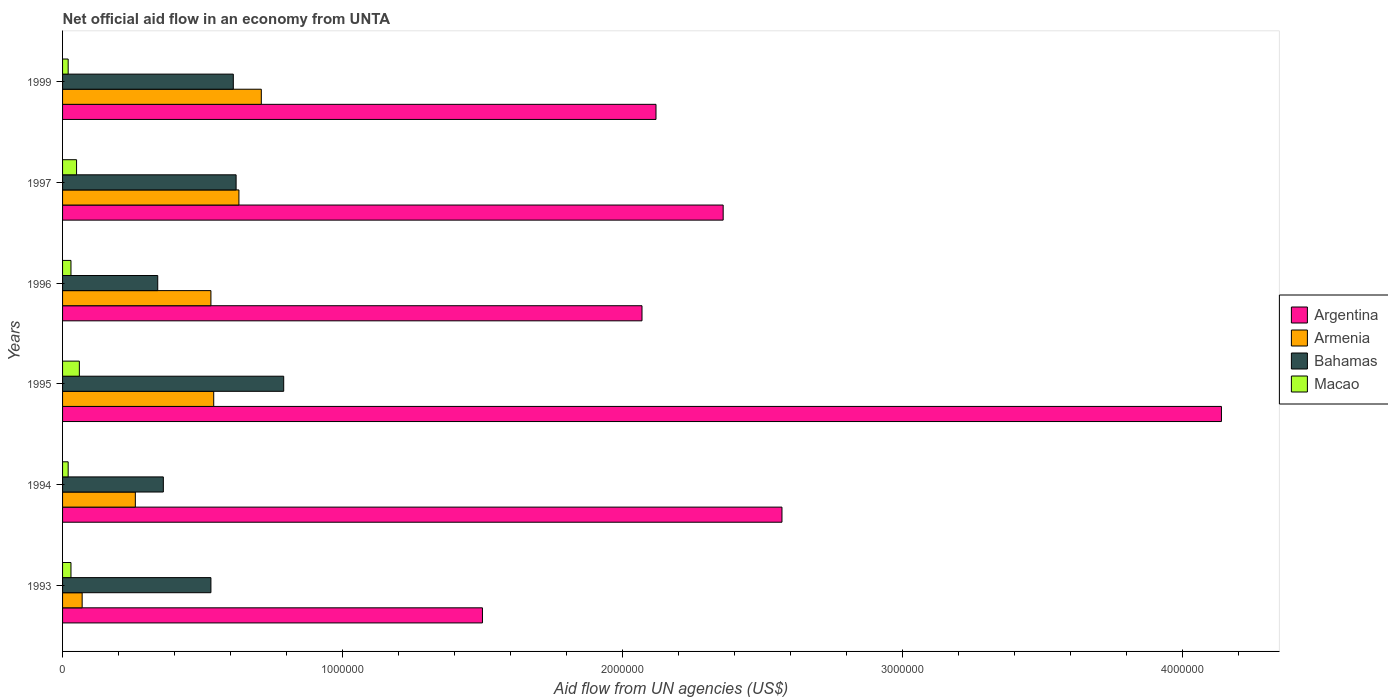Are the number of bars on each tick of the Y-axis equal?
Give a very brief answer. Yes. How many bars are there on the 2nd tick from the bottom?
Ensure brevity in your answer.  4. What is the label of the 4th group of bars from the top?
Your answer should be very brief. 1995. Across all years, what is the maximum net official aid flow in Argentina?
Provide a succinct answer. 4.14e+06. Across all years, what is the minimum net official aid flow in Bahamas?
Provide a short and direct response. 3.40e+05. In which year was the net official aid flow in Macao maximum?
Ensure brevity in your answer.  1995. In which year was the net official aid flow in Macao minimum?
Make the answer very short. 1994. What is the total net official aid flow in Argentina in the graph?
Offer a very short reply. 1.48e+07. What is the difference between the net official aid flow in Bahamas in 1996 and that in 1997?
Offer a very short reply. -2.80e+05. What is the difference between the net official aid flow in Argentina in 1995 and the net official aid flow in Bahamas in 1999?
Make the answer very short. 3.53e+06. What is the average net official aid flow in Argentina per year?
Offer a terse response. 2.46e+06. In the year 1994, what is the difference between the net official aid flow in Macao and net official aid flow in Argentina?
Your answer should be very brief. -2.55e+06. Is the net official aid flow in Bahamas in 1996 less than that in 1997?
Your response must be concise. Yes. What is the difference between the highest and the lowest net official aid flow in Bahamas?
Provide a succinct answer. 4.50e+05. In how many years, is the net official aid flow in Argentina greater than the average net official aid flow in Argentina taken over all years?
Keep it short and to the point. 2. What does the 4th bar from the top in 1996 represents?
Ensure brevity in your answer.  Argentina. What does the 3rd bar from the bottom in 1993 represents?
Offer a very short reply. Bahamas. Are all the bars in the graph horizontal?
Offer a terse response. Yes. How many years are there in the graph?
Keep it short and to the point. 6. What is the difference between two consecutive major ticks on the X-axis?
Give a very brief answer. 1.00e+06. Does the graph contain grids?
Ensure brevity in your answer.  No. How many legend labels are there?
Offer a terse response. 4. What is the title of the graph?
Offer a very short reply. Net official aid flow in an economy from UNTA. What is the label or title of the X-axis?
Provide a short and direct response. Aid flow from UN agencies (US$). What is the label or title of the Y-axis?
Keep it short and to the point. Years. What is the Aid flow from UN agencies (US$) of Argentina in 1993?
Your answer should be compact. 1.50e+06. What is the Aid flow from UN agencies (US$) of Armenia in 1993?
Your response must be concise. 7.00e+04. What is the Aid flow from UN agencies (US$) in Bahamas in 1993?
Ensure brevity in your answer.  5.30e+05. What is the Aid flow from UN agencies (US$) of Macao in 1993?
Offer a very short reply. 3.00e+04. What is the Aid flow from UN agencies (US$) of Argentina in 1994?
Make the answer very short. 2.57e+06. What is the Aid flow from UN agencies (US$) of Bahamas in 1994?
Make the answer very short. 3.60e+05. What is the Aid flow from UN agencies (US$) of Macao in 1994?
Keep it short and to the point. 2.00e+04. What is the Aid flow from UN agencies (US$) in Argentina in 1995?
Provide a short and direct response. 4.14e+06. What is the Aid flow from UN agencies (US$) of Armenia in 1995?
Ensure brevity in your answer.  5.40e+05. What is the Aid flow from UN agencies (US$) in Bahamas in 1995?
Your answer should be compact. 7.90e+05. What is the Aid flow from UN agencies (US$) in Argentina in 1996?
Provide a short and direct response. 2.07e+06. What is the Aid flow from UN agencies (US$) of Armenia in 1996?
Your answer should be very brief. 5.30e+05. What is the Aid flow from UN agencies (US$) in Argentina in 1997?
Give a very brief answer. 2.36e+06. What is the Aid flow from UN agencies (US$) of Armenia in 1997?
Ensure brevity in your answer.  6.30e+05. What is the Aid flow from UN agencies (US$) in Bahamas in 1997?
Give a very brief answer. 6.20e+05. What is the Aid flow from UN agencies (US$) of Argentina in 1999?
Your answer should be very brief. 2.12e+06. What is the Aid flow from UN agencies (US$) of Armenia in 1999?
Provide a short and direct response. 7.10e+05. What is the Aid flow from UN agencies (US$) of Bahamas in 1999?
Offer a terse response. 6.10e+05. What is the Aid flow from UN agencies (US$) of Macao in 1999?
Provide a succinct answer. 2.00e+04. Across all years, what is the maximum Aid flow from UN agencies (US$) in Argentina?
Make the answer very short. 4.14e+06. Across all years, what is the maximum Aid flow from UN agencies (US$) of Armenia?
Provide a short and direct response. 7.10e+05. Across all years, what is the maximum Aid flow from UN agencies (US$) in Bahamas?
Your answer should be compact. 7.90e+05. Across all years, what is the minimum Aid flow from UN agencies (US$) of Argentina?
Your answer should be compact. 1.50e+06. What is the total Aid flow from UN agencies (US$) of Argentina in the graph?
Your answer should be very brief. 1.48e+07. What is the total Aid flow from UN agencies (US$) in Armenia in the graph?
Your answer should be compact. 2.74e+06. What is the total Aid flow from UN agencies (US$) in Bahamas in the graph?
Keep it short and to the point. 3.25e+06. What is the difference between the Aid flow from UN agencies (US$) of Argentina in 1993 and that in 1994?
Provide a succinct answer. -1.07e+06. What is the difference between the Aid flow from UN agencies (US$) in Armenia in 1993 and that in 1994?
Give a very brief answer. -1.90e+05. What is the difference between the Aid flow from UN agencies (US$) in Bahamas in 1993 and that in 1994?
Provide a succinct answer. 1.70e+05. What is the difference between the Aid flow from UN agencies (US$) in Argentina in 1993 and that in 1995?
Your response must be concise. -2.64e+06. What is the difference between the Aid flow from UN agencies (US$) of Armenia in 1993 and that in 1995?
Give a very brief answer. -4.70e+05. What is the difference between the Aid flow from UN agencies (US$) in Bahamas in 1993 and that in 1995?
Ensure brevity in your answer.  -2.60e+05. What is the difference between the Aid flow from UN agencies (US$) of Argentina in 1993 and that in 1996?
Your answer should be compact. -5.70e+05. What is the difference between the Aid flow from UN agencies (US$) in Armenia in 1993 and that in 1996?
Provide a succinct answer. -4.60e+05. What is the difference between the Aid flow from UN agencies (US$) in Bahamas in 1993 and that in 1996?
Provide a short and direct response. 1.90e+05. What is the difference between the Aid flow from UN agencies (US$) in Argentina in 1993 and that in 1997?
Give a very brief answer. -8.60e+05. What is the difference between the Aid flow from UN agencies (US$) in Armenia in 1993 and that in 1997?
Your answer should be very brief. -5.60e+05. What is the difference between the Aid flow from UN agencies (US$) in Bahamas in 1993 and that in 1997?
Your answer should be compact. -9.00e+04. What is the difference between the Aid flow from UN agencies (US$) in Macao in 1993 and that in 1997?
Make the answer very short. -2.00e+04. What is the difference between the Aid flow from UN agencies (US$) in Argentina in 1993 and that in 1999?
Your response must be concise. -6.20e+05. What is the difference between the Aid flow from UN agencies (US$) of Armenia in 1993 and that in 1999?
Keep it short and to the point. -6.40e+05. What is the difference between the Aid flow from UN agencies (US$) in Bahamas in 1993 and that in 1999?
Make the answer very short. -8.00e+04. What is the difference between the Aid flow from UN agencies (US$) in Argentina in 1994 and that in 1995?
Ensure brevity in your answer.  -1.57e+06. What is the difference between the Aid flow from UN agencies (US$) in Armenia in 1994 and that in 1995?
Your answer should be compact. -2.80e+05. What is the difference between the Aid flow from UN agencies (US$) in Bahamas in 1994 and that in 1995?
Offer a terse response. -4.30e+05. What is the difference between the Aid flow from UN agencies (US$) in Macao in 1994 and that in 1995?
Offer a terse response. -4.00e+04. What is the difference between the Aid flow from UN agencies (US$) in Argentina in 1994 and that in 1996?
Make the answer very short. 5.00e+05. What is the difference between the Aid flow from UN agencies (US$) in Armenia in 1994 and that in 1996?
Offer a very short reply. -2.70e+05. What is the difference between the Aid flow from UN agencies (US$) in Macao in 1994 and that in 1996?
Provide a short and direct response. -10000. What is the difference between the Aid flow from UN agencies (US$) of Armenia in 1994 and that in 1997?
Give a very brief answer. -3.70e+05. What is the difference between the Aid flow from UN agencies (US$) of Bahamas in 1994 and that in 1997?
Offer a very short reply. -2.60e+05. What is the difference between the Aid flow from UN agencies (US$) in Armenia in 1994 and that in 1999?
Give a very brief answer. -4.50e+05. What is the difference between the Aid flow from UN agencies (US$) in Macao in 1994 and that in 1999?
Offer a very short reply. 0. What is the difference between the Aid flow from UN agencies (US$) in Argentina in 1995 and that in 1996?
Your answer should be compact. 2.07e+06. What is the difference between the Aid flow from UN agencies (US$) of Argentina in 1995 and that in 1997?
Your response must be concise. 1.78e+06. What is the difference between the Aid flow from UN agencies (US$) of Armenia in 1995 and that in 1997?
Ensure brevity in your answer.  -9.00e+04. What is the difference between the Aid flow from UN agencies (US$) in Bahamas in 1995 and that in 1997?
Your response must be concise. 1.70e+05. What is the difference between the Aid flow from UN agencies (US$) of Argentina in 1995 and that in 1999?
Provide a succinct answer. 2.02e+06. What is the difference between the Aid flow from UN agencies (US$) in Macao in 1995 and that in 1999?
Provide a short and direct response. 4.00e+04. What is the difference between the Aid flow from UN agencies (US$) of Argentina in 1996 and that in 1997?
Give a very brief answer. -2.90e+05. What is the difference between the Aid flow from UN agencies (US$) in Bahamas in 1996 and that in 1997?
Keep it short and to the point. -2.80e+05. What is the difference between the Aid flow from UN agencies (US$) of Macao in 1996 and that in 1997?
Make the answer very short. -2.00e+04. What is the difference between the Aid flow from UN agencies (US$) of Armenia in 1996 and that in 1999?
Ensure brevity in your answer.  -1.80e+05. What is the difference between the Aid flow from UN agencies (US$) of Macao in 1996 and that in 1999?
Your answer should be very brief. 10000. What is the difference between the Aid flow from UN agencies (US$) in Armenia in 1997 and that in 1999?
Offer a terse response. -8.00e+04. What is the difference between the Aid flow from UN agencies (US$) of Argentina in 1993 and the Aid flow from UN agencies (US$) of Armenia in 1994?
Your response must be concise. 1.24e+06. What is the difference between the Aid flow from UN agencies (US$) of Argentina in 1993 and the Aid flow from UN agencies (US$) of Bahamas in 1994?
Your response must be concise. 1.14e+06. What is the difference between the Aid flow from UN agencies (US$) in Argentina in 1993 and the Aid flow from UN agencies (US$) in Macao in 1994?
Provide a succinct answer. 1.48e+06. What is the difference between the Aid flow from UN agencies (US$) of Armenia in 1993 and the Aid flow from UN agencies (US$) of Bahamas in 1994?
Your answer should be compact. -2.90e+05. What is the difference between the Aid flow from UN agencies (US$) in Bahamas in 1993 and the Aid flow from UN agencies (US$) in Macao in 1994?
Keep it short and to the point. 5.10e+05. What is the difference between the Aid flow from UN agencies (US$) in Argentina in 1993 and the Aid flow from UN agencies (US$) in Armenia in 1995?
Make the answer very short. 9.60e+05. What is the difference between the Aid flow from UN agencies (US$) in Argentina in 1993 and the Aid flow from UN agencies (US$) in Bahamas in 1995?
Give a very brief answer. 7.10e+05. What is the difference between the Aid flow from UN agencies (US$) of Argentina in 1993 and the Aid flow from UN agencies (US$) of Macao in 1995?
Your answer should be very brief. 1.44e+06. What is the difference between the Aid flow from UN agencies (US$) of Armenia in 1993 and the Aid flow from UN agencies (US$) of Bahamas in 1995?
Give a very brief answer. -7.20e+05. What is the difference between the Aid flow from UN agencies (US$) of Armenia in 1993 and the Aid flow from UN agencies (US$) of Macao in 1995?
Ensure brevity in your answer.  10000. What is the difference between the Aid flow from UN agencies (US$) of Bahamas in 1993 and the Aid flow from UN agencies (US$) of Macao in 1995?
Your response must be concise. 4.70e+05. What is the difference between the Aid flow from UN agencies (US$) of Argentina in 1993 and the Aid flow from UN agencies (US$) of Armenia in 1996?
Give a very brief answer. 9.70e+05. What is the difference between the Aid flow from UN agencies (US$) in Argentina in 1993 and the Aid flow from UN agencies (US$) in Bahamas in 1996?
Your answer should be compact. 1.16e+06. What is the difference between the Aid flow from UN agencies (US$) of Argentina in 1993 and the Aid flow from UN agencies (US$) of Macao in 1996?
Make the answer very short. 1.47e+06. What is the difference between the Aid flow from UN agencies (US$) in Armenia in 1993 and the Aid flow from UN agencies (US$) in Macao in 1996?
Make the answer very short. 4.00e+04. What is the difference between the Aid flow from UN agencies (US$) of Argentina in 1993 and the Aid flow from UN agencies (US$) of Armenia in 1997?
Your answer should be very brief. 8.70e+05. What is the difference between the Aid flow from UN agencies (US$) of Argentina in 1993 and the Aid flow from UN agencies (US$) of Bahamas in 1997?
Your answer should be very brief. 8.80e+05. What is the difference between the Aid flow from UN agencies (US$) of Argentina in 1993 and the Aid flow from UN agencies (US$) of Macao in 1997?
Give a very brief answer. 1.45e+06. What is the difference between the Aid flow from UN agencies (US$) of Armenia in 1993 and the Aid flow from UN agencies (US$) of Bahamas in 1997?
Ensure brevity in your answer.  -5.50e+05. What is the difference between the Aid flow from UN agencies (US$) in Argentina in 1993 and the Aid flow from UN agencies (US$) in Armenia in 1999?
Your answer should be very brief. 7.90e+05. What is the difference between the Aid flow from UN agencies (US$) in Argentina in 1993 and the Aid flow from UN agencies (US$) in Bahamas in 1999?
Keep it short and to the point. 8.90e+05. What is the difference between the Aid flow from UN agencies (US$) in Argentina in 1993 and the Aid flow from UN agencies (US$) in Macao in 1999?
Your response must be concise. 1.48e+06. What is the difference between the Aid flow from UN agencies (US$) in Armenia in 1993 and the Aid flow from UN agencies (US$) in Bahamas in 1999?
Ensure brevity in your answer.  -5.40e+05. What is the difference between the Aid flow from UN agencies (US$) of Bahamas in 1993 and the Aid flow from UN agencies (US$) of Macao in 1999?
Offer a terse response. 5.10e+05. What is the difference between the Aid flow from UN agencies (US$) in Argentina in 1994 and the Aid flow from UN agencies (US$) in Armenia in 1995?
Your answer should be compact. 2.03e+06. What is the difference between the Aid flow from UN agencies (US$) of Argentina in 1994 and the Aid flow from UN agencies (US$) of Bahamas in 1995?
Ensure brevity in your answer.  1.78e+06. What is the difference between the Aid flow from UN agencies (US$) of Argentina in 1994 and the Aid flow from UN agencies (US$) of Macao in 1995?
Your answer should be compact. 2.51e+06. What is the difference between the Aid flow from UN agencies (US$) in Armenia in 1994 and the Aid flow from UN agencies (US$) in Bahamas in 1995?
Make the answer very short. -5.30e+05. What is the difference between the Aid flow from UN agencies (US$) in Bahamas in 1994 and the Aid flow from UN agencies (US$) in Macao in 1995?
Provide a short and direct response. 3.00e+05. What is the difference between the Aid flow from UN agencies (US$) of Argentina in 1994 and the Aid flow from UN agencies (US$) of Armenia in 1996?
Give a very brief answer. 2.04e+06. What is the difference between the Aid flow from UN agencies (US$) of Argentina in 1994 and the Aid flow from UN agencies (US$) of Bahamas in 1996?
Your response must be concise. 2.23e+06. What is the difference between the Aid flow from UN agencies (US$) in Argentina in 1994 and the Aid flow from UN agencies (US$) in Macao in 1996?
Provide a short and direct response. 2.54e+06. What is the difference between the Aid flow from UN agencies (US$) of Armenia in 1994 and the Aid flow from UN agencies (US$) of Bahamas in 1996?
Provide a succinct answer. -8.00e+04. What is the difference between the Aid flow from UN agencies (US$) of Bahamas in 1994 and the Aid flow from UN agencies (US$) of Macao in 1996?
Offer a terse response. 3.30e+05. What is the difference between the Aid flow from UN agencies (US$) in Argentina in 1994 and the Aid flow from UN agencies (US$) in Armenia in 1997?
Your answer should be very brief. 1.94e+06. What is the difference between the Aid flow from UN agencies (US$) in Argentina in 1994 and the Aid flow from UN agencies (US$) in Bahamas in 1997?
Keep it short and to the point. 1.95e+06. What is the difference between the Aid flow from UN agencies (US$) in Argentina in 1994 and the Aid flow from UN agencies (US$) in Macao in 1997?
Provide a succinct answer. 2.52e+06. What is the difference between the Aid flow from UN agencies (US$) in Armenia in 1994 and the Aid flow from UN agencies (US$) in Bahamas in 1997?
Your answer should be compact. -3.60e+05. What is the difference between the Aid flow from UN agencies (US$) in Bahamas in 1994 and the Aid flow from UN agencies (US$) in Macao in 1997?
Your answer should be very brief. 3.10e+05. What is the difference between the Aid flow from UN agencies (US$) in Argentina in 1994 and the Aid flow from UN agencies (US$) in Armenia in 1999?
Your response must be concise. 1.86e+06. What is the difference between the Aid flow from UN agencies (US$) in Argentina in 1994 and the Aid flow from UN agencies (US$) in Bahamas in 1999?
Provide a succinct answer. 1.96e+06. What is the difference between the Aid flow from UN agencies (US$) in Argentina in 1994 and the Aid flow from UN agencies (US$) in Macao in 1999?
Offer a terse response. 2.55e+06. What is the difference between the Aid flow from UN agencies (US$) in Armenia in 1994 and the Aid flow from UN agencies (US$) in Bahamas in 1999?
Make the answer very short. -3.50e+05. What is the difference between the Aid flow from UN agencies (US$) in Bahamas in 1994 and the Aid flow from UN agencies (US$) in Macao in 1999?
Keep it short and to the point. 3.40e+05. What is the difference between the Aid flow from UN agencies (US$) in Argentina in 1995 and the Aid flow from UN agencies (US$) in Armenia in 1996?
Ensure brevity in your answer.  3.61e+06. What is the difference between the Aid flow from UN agencies (US$) of Argentina in 1995 and the Aid flow from UN agencies (US$) of Bahamas in 1996?
Provide a succinct answer. 3.80e+06. What is the difference between the Aid flow from UN agencies (US$) of Argentina in 1995 and the Aid flow from UN agencies (US$) of Macao in 1996?
Provide a succinct answer. 4.11e+06. What is the difference between the Aid flow from UN agencies (US$) in Armenia in 1995 and the Aid flow from UN agencies (US$) in Macao in 1996?
Your answer should be compact. 5.10e+05. What is the difference between the Aid flow from UN agencies (US$) in Bahamas in 1995 and the Aid flow from UN agencies (US$) in Macao in 1996?
Ensure brevity in your answer.  7.60e+05. What is the difference between the Aid flow from UN agencies (US$) in Argentina in 1995 and the Aid flow from UN agencies (US$) in Armenia in 1997?
Ensure brevity in your answer.  3.51e+06. What is the difference between the Aid flow from UN agencies (US$) in Argentina in 1995 and the Aid flow from UN agencies (US$) in Bahamas in 1997?
Ensure brevity in your answer.  3.52e+06. What is the difference between the Aid flow from UN agencies (US$) of Argentina in 1995 and the Aid flow from UN agencies (US$) of Macao in 1997?
Provide a succinct answer. 4.09e+06. What is the difference between the Aid flow from UN agencies (US$) of Armenia in 1995 and the Aid flow from UN agencies (US$) of Macao in 1997?
Offer a terse response. 4.90e+05. What is the difference between the Aid flow from UN agencies (US$) of Bahamas in 1995 and the Aid flow from UN agencies (US$) of Macao in 1997?
Ensure brevity in your answer.  7.40e+05. What is the difference between the Aid flow from UN agencies (US$) of Argentina in 1995 and the Aid flow from UN agencies (US$) of Armenia in 1999?
Your answer should be compact. 3.43e+06. What is the difference between the Aid flow from UN agencies (US$) of Argentina in 1995 and the Aid flow from UN agencies (US$) of Bahamas in 1999?
Offer a terse response. 3.53e+06. What is the difference between the Aid flow from UN agencies (US$) of Argentina in 1995 and the Aid flow from UN agencies (US$) of Macao in 1999?
Ensure brevity in your answer.  4.12e+06. What is the difference between the Aid flow from UN agencies (US$) of Armenia in 1995 and the Aid flow from UN agencies (US$) of Macao in 1999?
Offer a terse response. 5.20e+05. What is the difference between the Aid flow from UN agencies (US$) of Bahamas in 1995 and the Aid flow from UN agencies (US$) of Macao in 1999?
Provide a succinct answer. 7.70e+05. What is the difference between the Aid flow from UN agencies (US$) in Argentina in 1996 and the Aid flow from UN agencies (US$) in Armenia in 1997?
Give a very brief answer. 1.44e+06. What is the difference between the Aid flow from UN agencies (US$) in Argentina in 1996 and the Aid flow from UN agencies (US$) in Bahamas in 1997?
Provide a succinct answer. 1.45e+06. What is the difference between the Aid flow from UN agencies (US$) of Argentina in 1996 and the Aid flow from UN agencies (US$) of Macao in 1997?
Offer a very short reply. 2.02e+06. What is the difference between the Aid flow from UN agencies (US$) in Armenia in 1996 and the Aid flow from UN agencies (US$) in Macao in 1997?
Offer a terse response. 4.80e+05. What is the difference between the Aid flow from UN agencies (US$) of Bahamas in 1996 and the Aid flow from UN agencies (US$) of Macao in 1997?
Your answer should be compact. 2.90e+05. What is the difference between the Aid flow from UN agencies (US$) in Argentina in 1996 and the Aid flow from UN agencies (US$) in Armenia in 1999?
Your response must be concise. 1.36e+06. What is the difference between the Aid flow from UN agencies (US$) of Argentina in 1996 and the Aid flow from UN agencies (US$) of Bahamas in 1999?
Offer a terse response. 1.46e+06. What is the difference between the Aid flow from UN agencies (US$) in Argentina in 1996 and the Aid flow from UN agencies (US$) in Macao in 1999?
Provide a succinct answer. 2.05e+06. What is the difference between the Aid flow from UN agencies (US$) in Armenia in 1996 and the Aid flow from UN agencies (US$) in Macao in 1999?
Your answer should be very brief. 5.10e+05. What is the difference between the Aid flow from UN agencies (US$) of Bahamas in 1996 and the Aid flow from UN agencies (US$) of Macao in 1999?
Offer a very short reply. 3.20e+05. What is the difference between the Aid flow from UN agencies (US$) of Argentina in 1997 and the Aid flow from UN agencies (US$) of Armenia in 1999?
Your response must be concise. 1.65e+06. What is the difference between the Aid flow from UN agencies (US$) in Argentina in 1997 and the Aid flow from UN agencies (US$) in Bahamas in 1999?
Make the answer very short. 1.75e+06. What is the difference between the Aid flow from UN agencies (US$) in Argentina in 1997 and the Aid flow from UN agencies (US$) in Macao in 1999?
Your answer should be compact. 2.34e+06. What is the average Aid flow from UN agencies (US$) of Argentina per year?
Offer a terse response. 2.46e+06. What is the average Aid flow from UN agencies (US$) of Armenia per year?
Provide a succinct answer. 4.57e+05. What is the average Aid flow from UN agencies (US$) of Bahamas per year?
Your response must be concise. 5.42e+05. What is the average Aid flow from UN agencies (US$) in Macao per year?
Your answer should be compact. 3.50e+04. In the year 1993, what is the difference between the Aid flow from UN agencies (US$) in Argentina and Aid flow from UN agencies (US$) in Armenia?
Your answer should be very brief. 1.43e+06. In the year 1993, what is the difference between the Aid flow from UN agencies (US$) in Argentina and Aid flow from UN agencies (US$) in Bahamas?
Your response must be concise. 9.70e+05. In the year 1993, what is the difference between the Aid flow from UN agencies (US$) of Argentina and Aid flow from UN agencies (US$) of Macao?
Ensure brevity in your answer.  1.47e+06. In the year 1993, what is the difference between the Aid flow from UN agencies (US$) of Armenia and Aid flow from UN agencies (US$) of Bahamas?
Make the answer very short. -4.60e+05. In the year 1993, what is the difference between the Aid flow from UN agencies (US$) of Bahamas and Aid flow from UN agencies (US$) of Macao?
Offer a very short reply. 5.00e+05. In the year 1994, what is the difference between the Aid flow from UN agencies (US$) of Argentina and Aid flow from UN agencies (US$) of Armenia?
Offer a very short reply. 2.31e+06. In the year 1994, what is the difference between the Aid flow from UN agencies (US$) in Argentina and Aid flow from UN agencies (US$) in Bahamas?
Your answer should be very brief. 2.21e+06. In the year 1994, what is the difference between the Aid flow from UN agencies (US$) of Argentina and Aid flow from UN agencies (US$) of Macao?
Your answer should be very brief. 2.55e+06. In the year 1995, what is the difference between the Aid flow from UN agencies (US$) in Argentina and Aid flow from UN agencies (US$) in Armenia?
Provide a short and direct response. 3.60e+06. In the year 1995, what is the difference between the Aid flow from UN agencies (US$) in Argentina and Aid flow from UN agencies (US$) in Bahamas?
Provide a short and direct response. 3.35e+06. In the year 1995, what is the difference between the Aid flow from UN agencies (US$) of Argentina and Aid flow from UN agencies (US$) of Macao?
Your response must be concise. 4.08e+06. In the year 1995, what is the difference between the Aid flow from UN agencies (US$) in Bahamas and Aid flow from UN agencies (US$) in Macao?
Ensure brevity in your answer.  7.30e+05. In the year 1996, what is the difference between the Aid flow from UN agencies (US$) of Argentina and Aid flow from UN agencies (US$) of Armenia?
Give a very brief answer. 1.54e+06. In the year 1996, what is the difference between the Aid flow from UN agencies (US$) in Argentina and Aid flow from UN agencies (US$) in Bahamas?
Your response must be concise. 1.73e+06. In the year 1996, what is the difference between the Aid flow from UN agencies (US$) of Argentina and Aid flow from UN agencies (US$) of Macao?
Ensure brevity in your answer.  2.04e+06. In the year 1996, what is the difference between the Aid flow from UN agencies (US$) in Armenia and Aid flow from UN agencies (US$) in Bahamas?
Provide a succinct answer. 1.90e+05. In the year 1997, what is the difference between the Aid flow from UN agencies (US$) of Argentina and Aid flow from UN agencies (US$) of Armenia?
Your answer should be compact. 1.73e+06. In the year 1997, what is the difference between the Aid flow from UN agencies (US$) in Argentina and Aid flow from UN agencies (US$) in Bahamas?
Your answer should be compact. 1.74e+06. In the year 1997, what is the difference between the Aid flow from UN agencies (US$) in Argentina and Aid flow from UN agencies (US$) in Macao?
Your response must be concise. 2.31e+06. In the year 1997, what is the difference between the Aid flow from UN agencies (US$) of Armenia and Aid flow from UN agencies (US$) of Bahamas?
Your answer should be very brief. 10000. In the year 1997, what is the difference between the Aid flow from UN agencies (US$) of Armenia and Aid flow from UN agencies (US$) of Macao?
Offer a terse response. 5.80e+05. In the year 1997, what is the difference between the Aid flow from UN agencies (US$) of Bahamas and Aid flow from UN agencies (US$) of Macao?
Offer a very short reply. 5.70e+05. In the year 1999, what is the difference between the Aid flow from UN agencies (US$) of Argentina and Aid flow from UN agencies (US$) of Armenia?
Your answer should be compact. 1.41e+06. In the year 1999, what is the difference between the Aid flow from UN agencies (US$) in Argentina and Aid flow from UN agencies (US$) in Bahamas?
Provide a succinct answer. 1.51e+06. In the year 1999, what is the difference between the Aid flow from UN agencies (US$) of Argentina and Aid flow from UN agencies (US$) of Macao?
Offer a very short reply. 2.10e+06. In the year 1999, what is the difference between the Aid flow from UN agencies (US$) of Armenia and Aid flow from UN agencies (US$) of Macao?
Give a very brief answer. 6.90e+05. In the year 1999, what is the difference between the Aid flow from UN agencies (US$) in Bahamas and Aid flow from UN agencies (US$) in Macao?
Give a very brief answer. 5.90e+05. What is the ratio of the Aid flow from UN agencies (US$) of Argentina in 1993 to that in 1994?
Your answer should be very brief. 0.58. What is the ratio of the Aid flow from UN agencies (US$) of Armenia in 1993 to that in 1994?
Your answer should be compact. 0.27. What is the ratio of the Aid flow from UN agencies (US$) in Bahamas in 1993 to that in 1994?
Offer a very short reply. 1.47. What is the ratio of the Aid flow from UN agencies (US$) in Argentina in 1993 to that in 1995?
Ensure brevity in your answer.  0.36. What is the ratio of the Aid flow from UN agencies (US$) of Armenia in 1993 to that in 1995?
Make the answer very short. 0.13. What is the ratio of the Aid flow from UN agencies (US$) in Bahamas in 1993 to that in 1995?
Your answer should be very brief. 0.67. What is the ratio of the Aid flow from UN agencies (US$) in Argentina in 1993 to that in 1996?
Ensure brevity in your answer.  0.72. What is the ratio of the Aid flow from UN agencies (US$) of Armenia in 1993 to that in 1996?
Make the answer very short. 0.13. What is the ratio of the Aid flow from UN agencies (US$) in Bahamas in 1993 to that in 1996?
Your response must be concise. 1.56. What is the ratio of the Aid flow from UN agencies (US$) of Macao in 1993 to that in 1996?
Make the answer very short. 1. What is the ratio of the Aid flow from UN agencies (US$) of Argentina in 1993 to that in 1997?
Provide a succinct answer. 0.64. What is the ratio of the Aid flow from UN agencies (US$) of Bahamas in 1993 to that in 1997?
Keep it short and to the point. 0.85. What is the ratio of the Aid flow from UN agencies (US$) in Argentina in 1993 to that in 1999?
Your response must be concise. 0.71. What is the ratio of the Aid flow from UN agencies (US$) of Armenia in 1993 to that in 1999?
Your response must be concise. 0.1. What is the ratio of the Aid flow from UN agencies (US$) of Bahamas in 1993 to that in 1999?
Keep it short and to the point. 0.87. What is the ratio of the Aid flow from UN agencies (US$) of Argentina in 1994 to that in 1995?
Your answer should be compact. 0.62. What is the ratio of the Aid flow from UN agencies (US$) of Armenia in 1994 to that in 1995?
Make the answer very short. 0.48. What is the ratio of the Aid flow from UN agencies (US$) of Bahamas in 1994 to that in 1995?
Keep it short and to the point. 0.46. What is the ratio of the Aid flow from UN agencies (US$) of Macao in 1994 to that in 1995?
Ensure brevity in your answer.  0.33. What is the ratio of the Aid flow from UN agencies (US$) of Argentina in 1994 to that in 1996?
Provide a succinct answer. 1.24. What is the ratio of the Aid flow from UN agencies (US$) of Armenia in 1994 to that in 1996?
Offer a very short reply. 0.49. What is the ratio of the Aid flow from UN agencies (US$) in Bahamas in 1994 to that in 1996?
Give a very brief answer. 1.06. What is the ratio of the Aid flow from UN agencies (US$) of Macao in 1994 to that in 1996?
Keep it short and to the point. 0.67. What is the ratio of the Aid flow from UN agencies (US$) in Argentina in 1994 to that in 1997?
Offer a very short reply. 1.09. What is the ratio of the Aid flow from UN agencies (US$) in Armenia in 1994 to that in 1997?
Your response must be concise. 0.41. What is the ratio of the Aid flow from UN agencies (US$) of Bahamas in 1994 to that in 1997?
Keep it short and to the point. 0.58. What is the ratio of the Aid flow from UN agencies (US$) in Macao in 1994 to that in 1997?
Provide a short and direct response. 0.4. What is the ratio of the Aid flow from UN agencies (US$) of Argentina in 1994 to that in 1999?
Your response must be concise. 1.21. What is the ratio of the Aid flow from UN agencies (US$) of Armenia in 1994 to that in 1999?
Make the answer very short. 0.37. What is the ratio of the Aid flow from UN agencies (US$) in Bahamas in 1994 to that in 1999?
Ensure brevity in your answer.  0.59. What is the ratio of the Aid flow from UN agencies (US$) of Macao in 1994 to that in 1999?
Ensure brevity in your answer.  1. What is the ratio of the Aid flow from UN agencies (US$) in Argentina in 1995 to that in 1996?
Your response must be concise. 2. What is the ratio of the Aid flow from UN agencies (US$) in Armenia in 1995 to that in 1996?
Offer a very short reply. 1.02. What is the ratio of the Aid flow from UN agencies (US$) in Bahamas in 1995 to that in 1996?
Give a very brief answer. 2.32. What is the ratio of the Aid flow from UN agencies (US$) in Macao in 1995 to that in 1996?
Provide a succinct answer. 2. What is the ratio of the Aid flow from UN agencies (US$) of Argentina in 1995 to that in 1997?
Offer a terse response. 1.75. What is the ratio of the Aid flow from UN agencies (US$) in Bahamas in 1995 to that in 1997?
Provide a succinct answer. 1.27. What is the ratio of the Aid flow from UN agencies (US$) of Argentina in 1995 to that in 1999?
Make the answer very short. 1.95. What is the ratio of the Aid flow from UN agencies (US$) in Armenia in 1995 to that in 1999?
Give a very brief answer. 0.76. What is the ratio of the Aid flow from UN agencies (US$) of Bahamas in 1995 to that in 1999?
Your answer should be compact. 1.3. What is the ratio of the Aid flow from UN agencies (US$) of Macao in 1995 to that in 1999?
Offer a very short reply. 3. What is the ratio of the Aid flow from UN agencies (US$) of Argentina in 1996 to that in 1997?
Keep it short and to the point. 0.88. What is the ratio of the Aid flow from UN agencies (US$) of Armenia in 1996 to that in 1997?
Offer a very short reply. 0.84. What is the ratio of the Aid flow from UN agencies (US$) in Bahamas in 1996 to that in 1997?
Ensure brevity in your answer.  0.55. What is the ratio of the Aid flow from UN agencies (US$) in Argentina in 1996 to that in 1999?
Your response must be concise. 0.98. What is the ratio of the Aid flow from UN agencies (US$) in Armenia in 1996 to that in 1999?
Offer a terse response. 0.75. What is the ratio of the Aid flow from UN agencies (US$) of Bahamas in 1996 to that in 1999?
Make the answer very short. 0.56. What is the ratio of the Aid flow from UN agencies (US$) in Argentina in 1997 to that in 1999?
Your answer should be compact. 1.11. What is the ratio of the Aid flow from UN agencies (US$) in Armenia in 1997 to that in 1999?
Give a very brief answer. 0.89. What is the ratio of the Aid flow from UN agencies (US$) in Bahamas in 1997 to that in 1999?
Make the answer very short. 1.02. What is the difference between the highest and the second highest Aid flow from UN agencies (US$) of Argentina?
Your answer should be compact. 1.57e+06. What is the difference between the highest and the lowest Aid flow from UN agencies (US$) of Argentina?
Offer a terse response. 2.64e+06. What is the difference between the highest and the lowest Aid flow from UN agencies (US$) in Armenia?
Provide a succinct answer. 6.40e+05. What is the difference between the highest and the lowest Aid flow from UN agencies (US$) of Bahamas?
Your answer should be compact. 4.50e+05. 